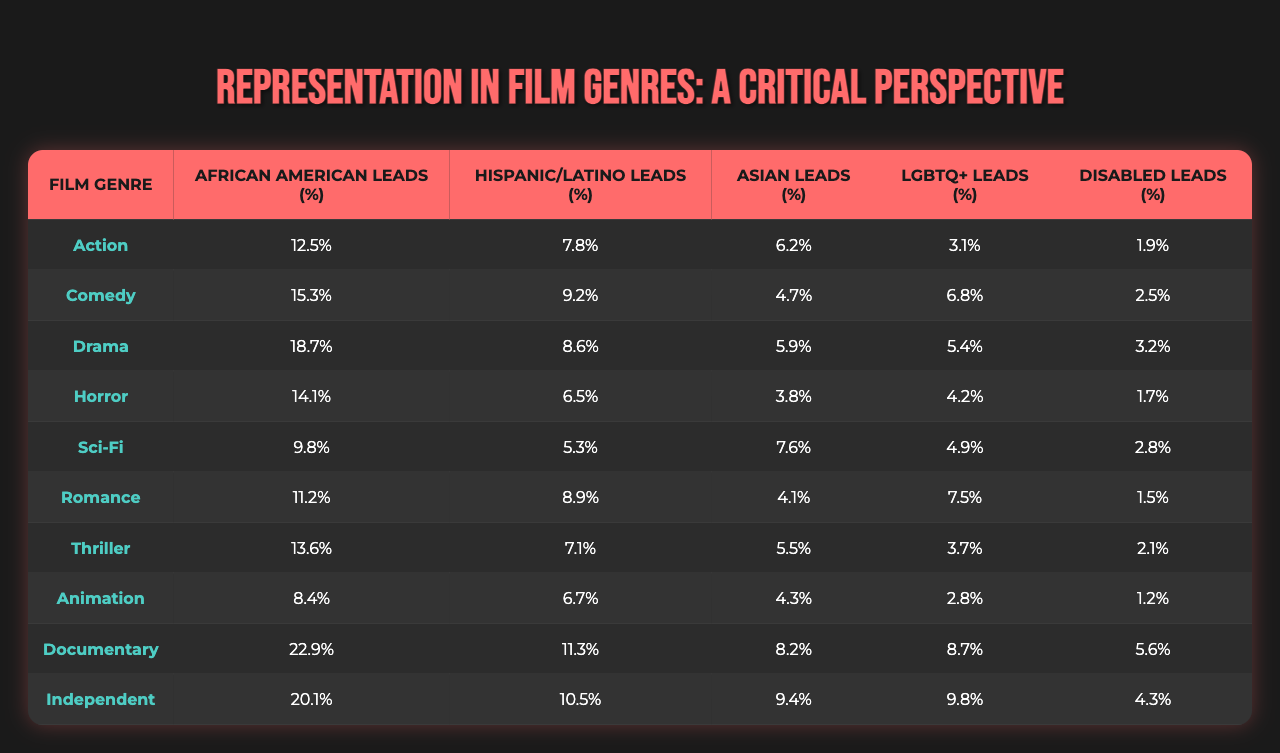What is the percentage of African American leads in the Action genre? From the table, the percentage of African American leads in the Action genre is stated directly in the corresponding cell. It shows 12.5%.
Answer: 12.5% Which genre has the highest percentage of LGBTQ+ leads? By examining the LGBTQ+ leads column for each genre, the highest percentage is found in the Documentary genre with 8.7%.
Answer: 8.7% Calculate the average percentage of Hispanic/Latino leads across all genres. The percentages of Hispanic/Latino leads for each genre are summed: 7.8 + 9.2 + 8.6 + 6.5 + 5.3 + 8.9 + 7.1 + 6.7 + 11.3 + 10.5 = 80.3. There are ten genres, so the average is 80.3/10 = 8.03%.
Answer: 8.03% Is the percentage of Disabled leads higher in the Comedy genre compared to the Sci-Fi genre? From the table, the Comedy genre shows 2.5% Disabled leads, whereas the Sci-Fi genre shows 2.8%. Since 2.8% is greater than 2.5%, the statement is false.
Answer: No Which genre has the lowest percentage of Asian leads, and what is that percentage? By examining the Asian leads column, the lowest percentage is found in the Horror genre with 3.8%.
Answer: Horror, 3.8% What is the difference in percentage of African American leads between the Drama and Independent genres? The percentage of African American leads in Drama is 18.7%, and for Independent, it is 20.1%. Therefore, the difference is 20.1% - 18.7% = 1.4%.
Answer: 1.4% Are there more genres with above 10% of African American leads than below 10%? Check the percentage: Action (12.5), Comedy (15.3), Drama (18.7), Horror (14.1), Sci-Fi (9.8), Romance (11.2), Thriller (13.6), Documentary (22.9), Independent (20.1) gives 8 genres above 10% and 2 below 10%. Thus, there are more genres with above 10%.
Answer: Yes What is the total percentage of Asian leads across all genres? The percentages of Asian leads (6.2 + 4.7 + 5.9 + 3.8 + 7.6 + 4.1 + 5.5 + 4.3 + 8.2 + 9.4) are added together to get 60.3%.
Answer: 60.3% How do the percentages of LGBTQ+ leads compare between Animation and Horror genres? For Animation, the percentage of LGBTQ+ leads is 2.8% and for Horror, it is 4.2%. Since 4.2% is greater than 2.8%, Horror has a higher percentage.
Answer: Horror is higher Find the percentage of Hispanic/Latino leads in the genre with the second-highest representation of Disabled leads. The Disabled leads percentage is highest in Documentary (5.6%) and next in Drama (3.2%). The corresponding percentage of Hispanic/Latino leads in Drama is 8.6%.
Answer: 8.6% 